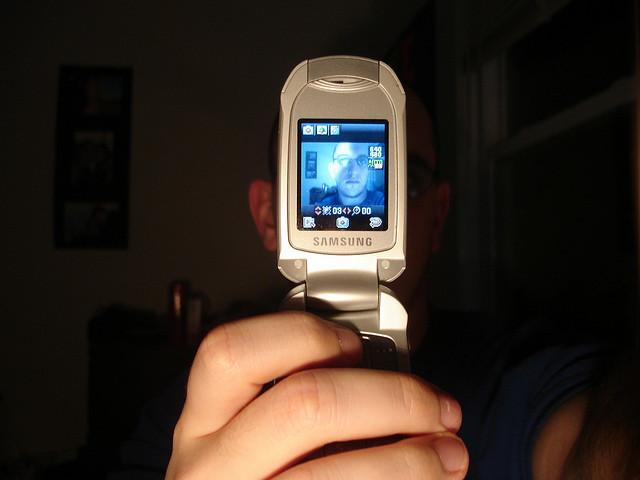What company makes the phone?

Choices:
A) apple
B) nokia
C) ibm
D) samsung samsung 